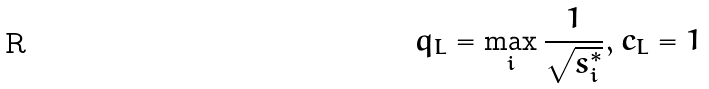Convert formula to latex. <formula><loc_0><loc_0><loc_500><loc_500>q _ { L } = \max _ { i } \frac { 1 } { \sqrt { s _ { i } ^ { * } } } , c _ { L } = 1</formula> 